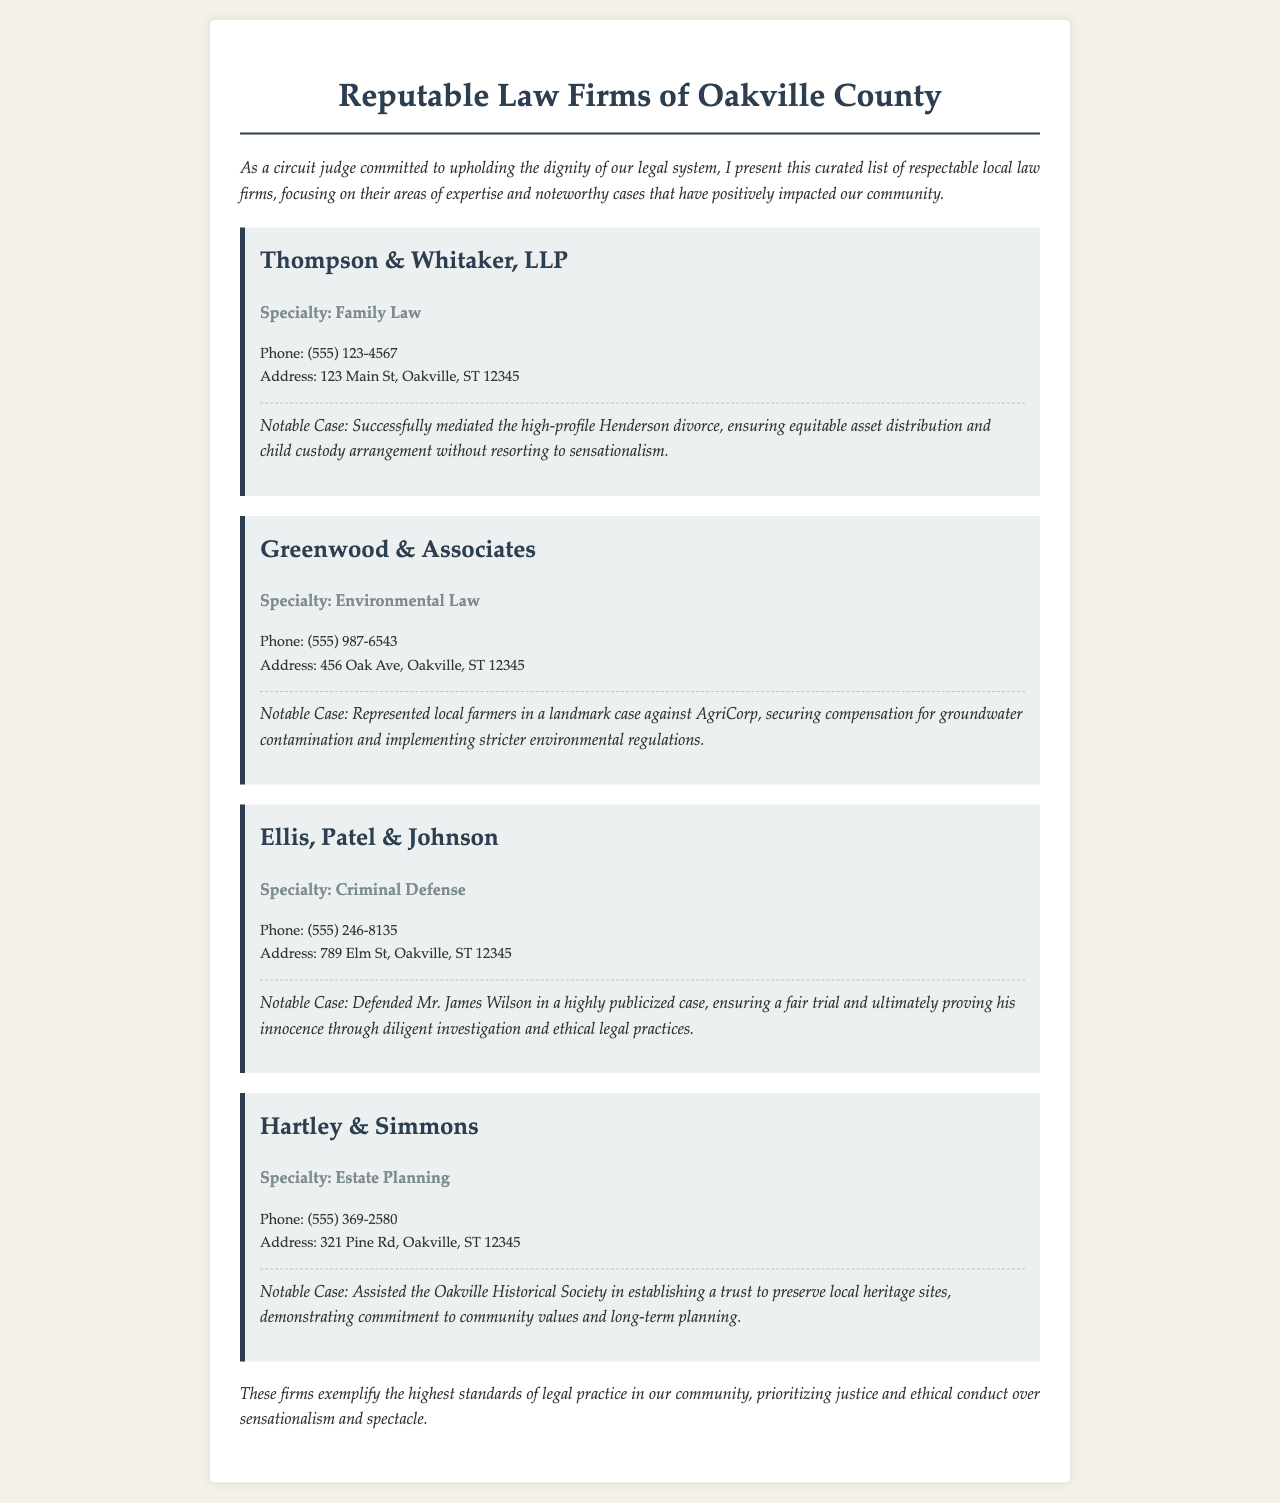What is the specialty of Thompson & Whitaker, LLP? The specialty is listed under the firm's information in the document.
Answer: Family Law What is the contact phone number for Greenwood & Associates? The phone number is provided in the contact section for Greenwood & Associates in the document.
Answer: (555) 987-6543 Who was the defendant in the publicized case handled by Ellis, Patel & Johnson? The defendant's name is mentioned in the notable case description for Ellis, Patel & Johnson.
Answer: Mr. James Wilson What area of law does Hartley & Simmons focus on? The area of law specialty is highlighted in the firm's section within the document.
Answer: Estate Planning What notable case did Greenwood & Associates handle? The document includes a description of a notable case under Greenwood & Associates.
Answer: Landmark case against AgriCorp Which law firm aided the Oakville Historical Society? The assisting law firm is specified in the notable case for Hartley & Simmons.
Answer: Hartley & Simmons How many law firms are listed in the document? The total number can be counted by examining the number of firm sections.
Answer: Four What is the address of Ellis, Patel & Johnson? The full address is provided in the contact section for the firm.
Answer: 789 Elm St, Oakville, ST 12345 What common theme is emphasized in the introduction of the document? The introduction highlights important principles relevant to legal practice in the community.
Answer: Dignity of our legal system 